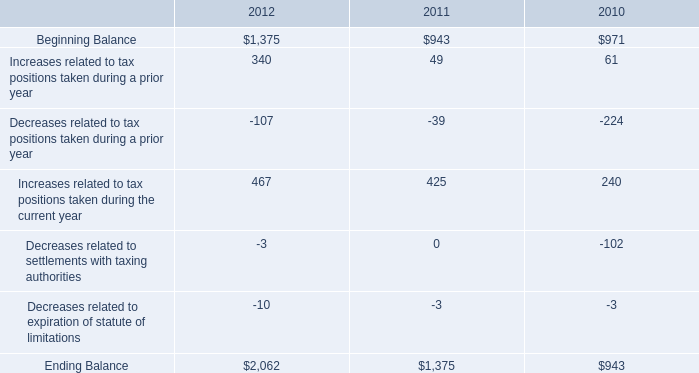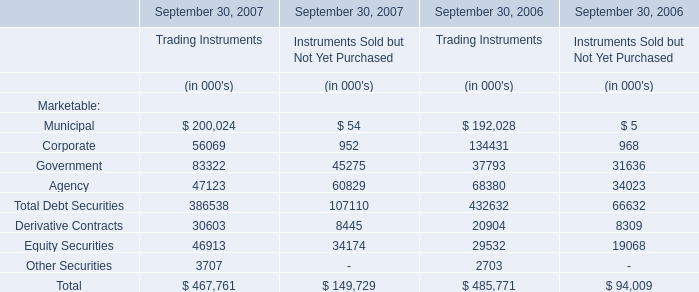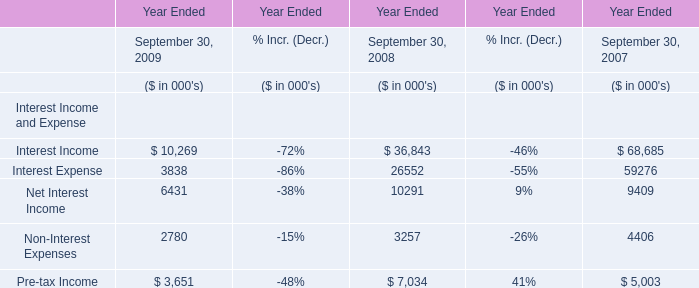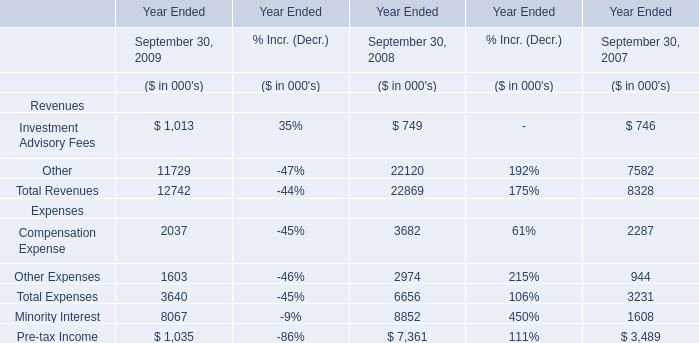what was the percentage change in the gross unrecognized tax benefits between 2010 and 2011? 
Computations: ((1375 - 943) / 943)
Answer: 0.45811. 